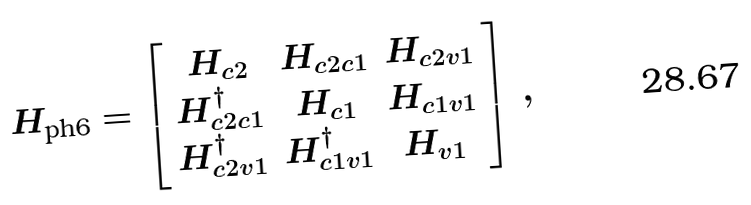Convert formula to latex. <formula><loc_0><loc_0><loc_500><loc_500>H _ { \text {ph6} } = \left [ \begin{array} { c c c } H _ { c 2 } & H _ { c 2 c 1 } & H _ { c 2 v 1 } \\ H _ { c 2 c 1 } ^ { \dagger } & H _ { c 1 } & H _ { c 1 v 1 } \\ H _ { c 2 v 1 } ^ { \dagger } & H _ { c 1 v 1 } ^ { \dagger } & H _ { v 1 } \end{array} \right ] \, ,</formula> 